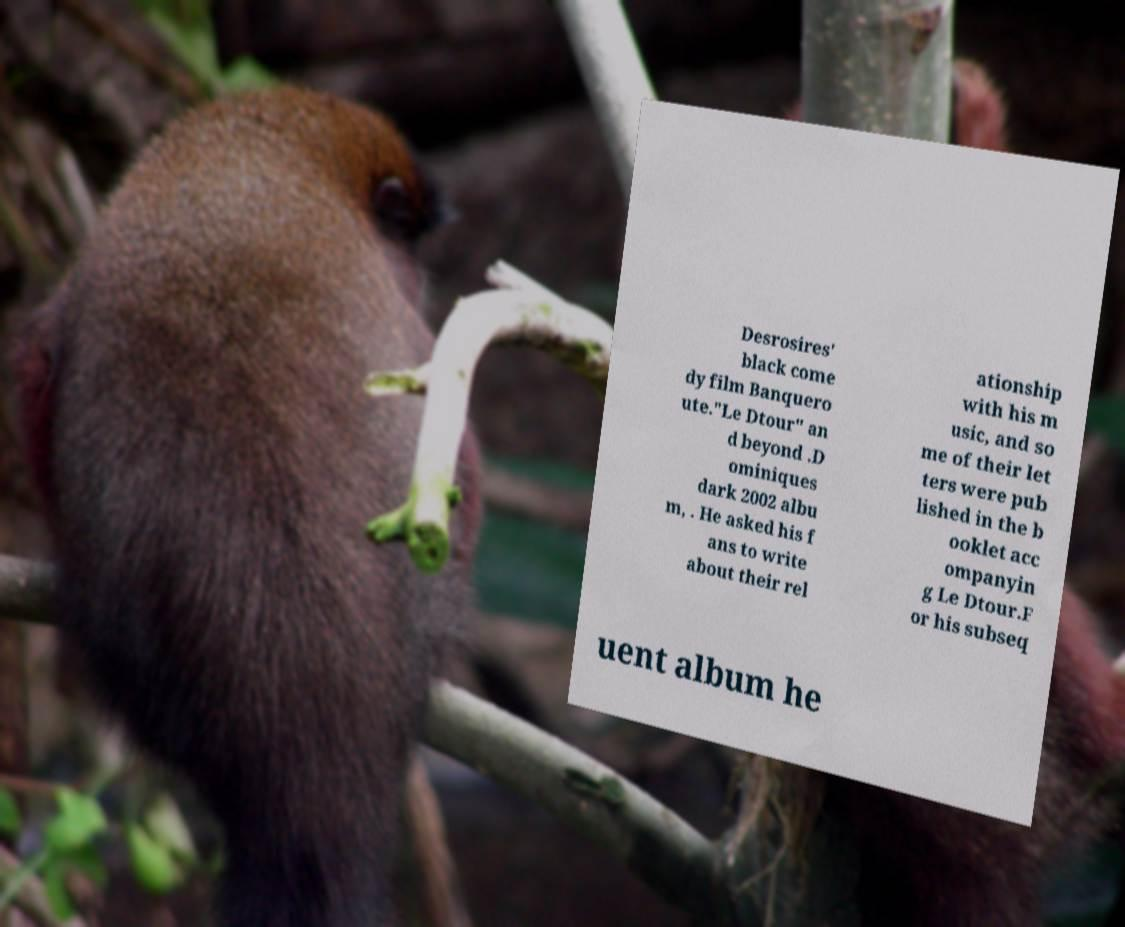There's text embedded in this image that I need extracted. Can you transcribe it verbatim? Desrosires' black come dy film Banquero ute."Le Dtour" an d beyond .D ominiques dark 2002 albu m, . He asked his f ans to write about their rel ationship with his m usic, and so me of their let ters were pub lished in the b ooklet acc ompanyin g Le Dtour.F or his subseq uent album he 